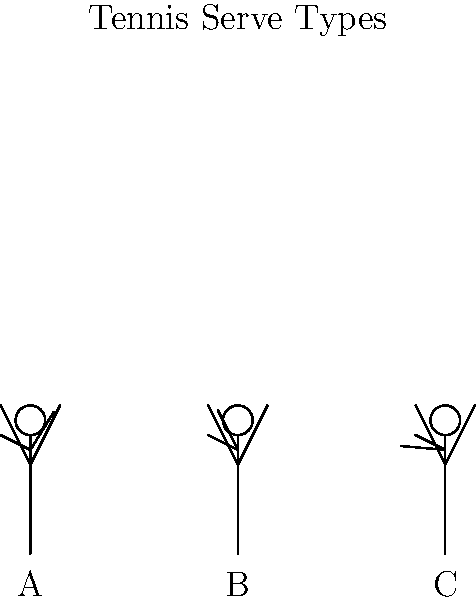Based on the motion capture data visualized as stick figures above, which figure most likely represents the initial position for a slice serve, a technique often used by Ilie Năstase? To answer this question, let's analyze each stick figure and relate it to different types of tennis serves:

1. Figure A (leftmost):
   - The serving arm is at approximately a 45-degree angle.
   - This position is typically associated with a flat serve or the beginning of a topspin serve.

2. Figure B (center):
   - The serving arm is raised to about a 90-degree angle.
   - This position could be the start of various serve types but is not distinctive enough for a slice serve.

3. Figure C (rightmost):
   - The serving arm is raised high, at about a 135-degree angle.
   - The body appears to be slightly arched backward.
   - This position is characteristic of the preparation for a slice serve.

The slice serve, a technique often employed by Ilie Năstase, requires a high toss and a distinctive sideways motion of the racquet to impart sidespin on the ball. The high arm position in Figure C allows for this sideways motion during the downswing, which is crucial for generating the slice effect.

Năstase was known for his varied and unpredictable serve, with the slice serve being one of his effective weapons. The high preparation position allowed him to disguise his serves and execute the slice with maximum effect.
Answer: Figure C 